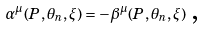<formula> <loc_0><loc_0><loc_500><loc_500>\alpha ^ { \mu } ( P , \theta _ { n } , \xi ) = - \beta ^ { \mu } ( P , \theta _ { n } , \xi ) \text {\,,}</formula> 